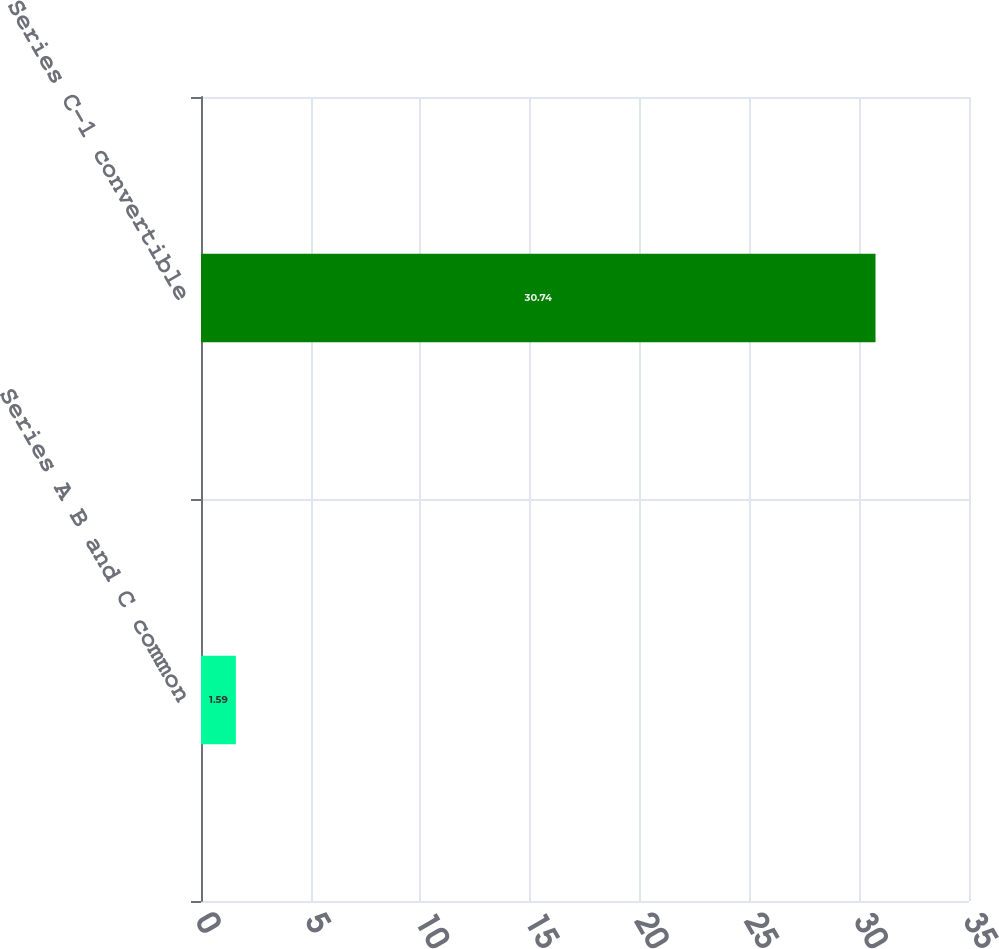Convert chart to OTSL. <chart><loc_0><loc_0><loc_500><loc_500><bar_chart><fcel>Series A B and C common<fcel>Series C-1 convertible<nl><fcel>1.59<fcel>30.74<nl></chart> 